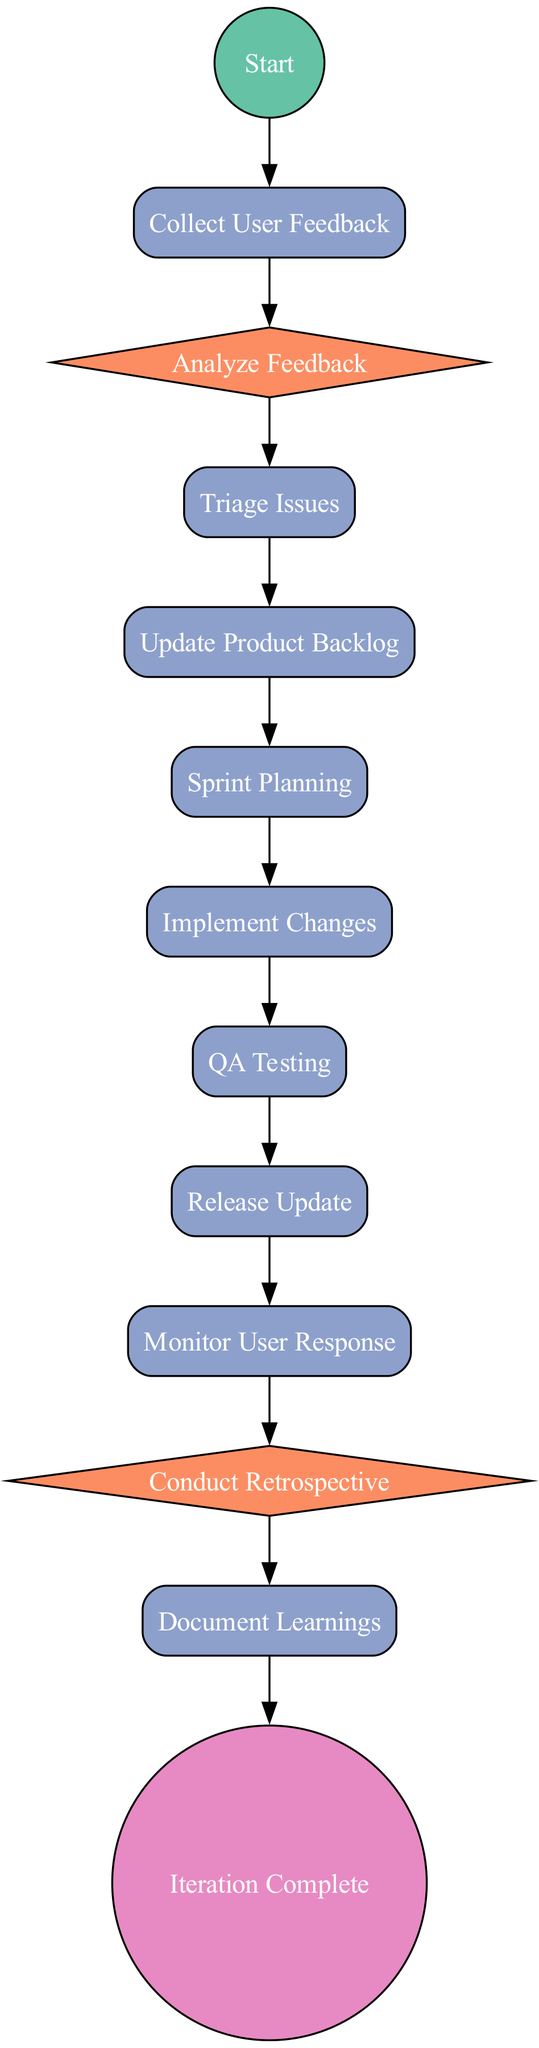What is the starting point of the flowchart? The starting point of the flowchart is represented by the node labeled "Start". It is the first element in the flow of the process, indicating where the user feedback and iteration cycle begins.
Answer: Start How many total process nodes are there in the flowchart? The flowchart contains six process nodes, which are "Collect User Feedback," "Triage Issues," "Update Product Backlog," "Sprint Planning," "Implement Changes," "QA Testing," and "Release Update."
Answer: Six What comes after "Collect User Feedback"? The process directly following "Collect User Feedback" is "Analyze Feedback", indicating that after gathering feedback, the next step is to evaluate it.
Answer: Analyze Feedback In which node do we assess what went well or didn’t? We assess what went well or didn’t in the node labeled "Conduct Retrospective", which is specifically designated for discussing successes and challenges within the process.
Answer: Conduct Retrospective What type of node is "Triage Issues"? The node "Triage Issues" is classified as a process node. This means it represents an action or a step that needs to be undertaken within the flow of the feedback and iteration cycle.
Answer: Process How many connections lead to "Release Update"? There is one connection that directly leads to "Release Update", which is from the "QA Testing" node, indicating that testing must be completed before an update is released.
Answer: One What is the final action after "Document Learnings"? The final action after "Document Learnings" is represented by the node labeled "Iteration Complete," marking the end of the feedback and iteration cycle process.
Answer: Iteration Complete What leads to the "Monitor User Response" node? The node leading to "Monitor User Response" is "Release Update," indicating that after the update deployment, user reaction and performance monitoring is the subsequent step.
Answer: Release Update Which node follows "Analyze Feedback"? The node that follows "Analyze Feedback" is "Triage Issues," which means that after analyzing feedback, the next action involves prioritizing the identified issues.
Answer: Triage Issues 